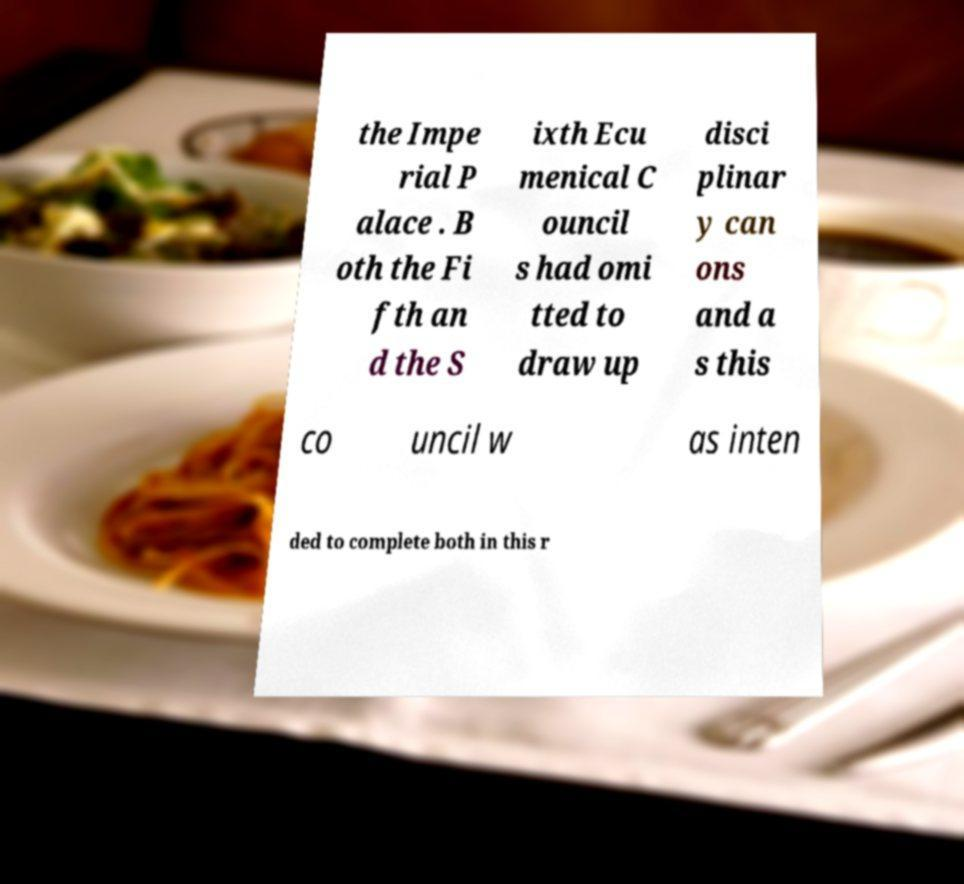For documentation purposes, I need the text within this image transcribed. Could you provide that? the Impe rial P alace . B oth the Fi fth an d the S ixth Ecu menical C ouncil s had omi tted to draw up disci plinar y can ons and a s this co uncil w as inten ded to complete both in this r 